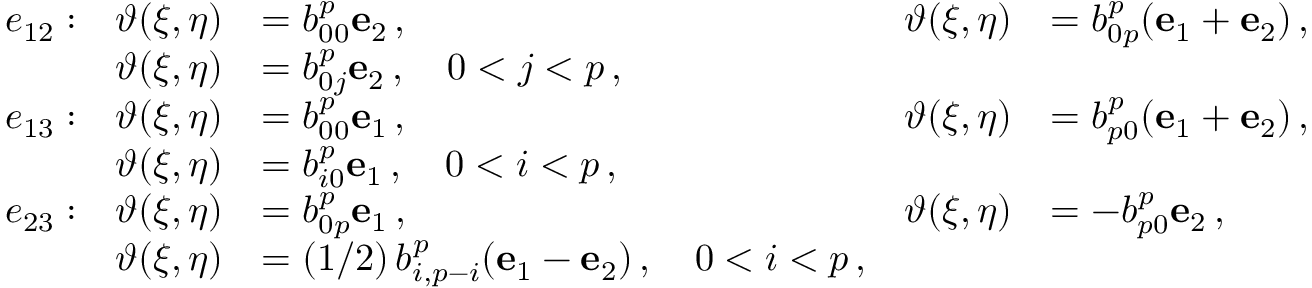Convert formula to latex. <formula><loc_0><loc_0><loc_500><loc_500>\begin{array} { r l r l r l } & { e _ { 1 2 } \colon } & { \vartheta ( \xi , \eta ) } & { = b _ { 0 0 } ^ { p } e _ { 2 } \, , } & { \vartheta ( \xi , \eta ) } & { = b _ { 0 p } ^ { p } ( e _ { 1 } + e _ { 2 } ) \, , } \\ & { \vartheta ( \xi , \eta ) } & { = b _ { 0 j } ^ { p } e _ { 2 } \, , \quad 0 < j < p \, , } \\ & { e _ { 1 3 } \colon } & { \vartheta ( \xi , \eta ) } & { = b _ { 0 0 } ^ { p } e _ { 1 } \, , } & { \vartheta ( \xi , \eta ) } & { = b _ { p 0 } ^ { p } ( e _ { 1 } + e _ { 2 } ) \, , } \\ & { \vartheta ( \xi , \eta ) } & { = b _ { i 0 } ^ { p } e _ { 1 } \, , \quad 0 < i < p \, , } \\ & { e _ { 2 3 } \colon } & { \vartheta ( \xi , \eta ) } & { = b _ { 0 p } ^ { p } e _ { 1 } \, , } & { \vartheta ( \xi , \eta ) } & { = - b _ { p 0 } ^ { p } e _ { 2 } \, , } \\ & { \vartheta ( \xi , \eta ) } & { = ( 1 / 2 ) \, b _ { i , p - i } ^ { p } ( e _ { 1 } - e _ { 2 } ) \, , \quad 0 < i < p \, , } \end{array}</formula> 